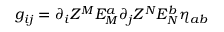Convert formula to latex. <formula><loc_0><loc_0><loc_500><loc_500>g _ { i j } = \partial _ { i } Z ^ { M } E _ { M } ^ { a } \partial _ { j } Z ^ { N } E _ { N } ^ { b } \eta _ { a b }</formula> 